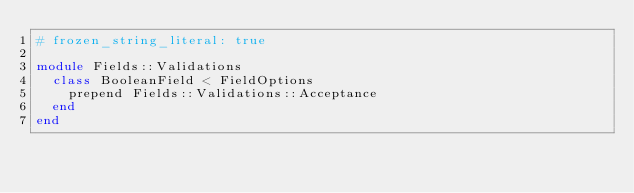<code> <loc_0><loc_0><loc_500><loc_500><_Ruby_># frozen_string_literal: true

module Fields::Validations
  class BooleanField < FieldOptions
    prepend Fields::Validations::Acceptance
  end
end
</code> 